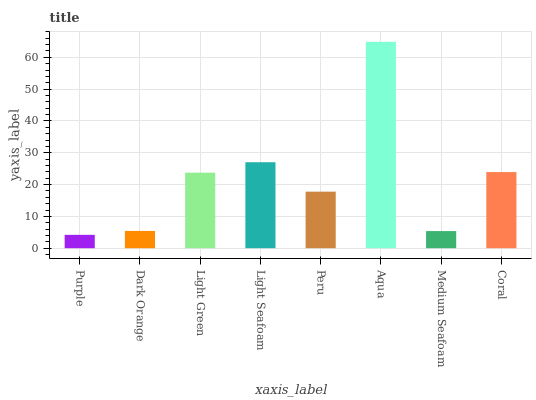Is Purple the minimum?
Answer yes or no. Yes. Is Aqua the maximum?
Answer yes or no. Yes. Is Dark Orange the minimum?
Answer yes or no. No. Is Dark Orange the maximum?
Answer yes or no. No. Is Dark Orange greater than Purple?
Answer yes or no. Yes. Is Purple less than Dark Orange?
Answer yes or no. Yes. Is Purple greater than Dark Orange?
Answer yes or no. No. Is Dark Orange less than Purple?
Answer yes or no. No. Is Light Green the high median?
Answer yes or no. Yes. Is Peru the low median?
Answer yes or no. Yes. Is Purple the high median?
Answer yes or no. No. Is Purple the low median?
Answer yes or no. No. 